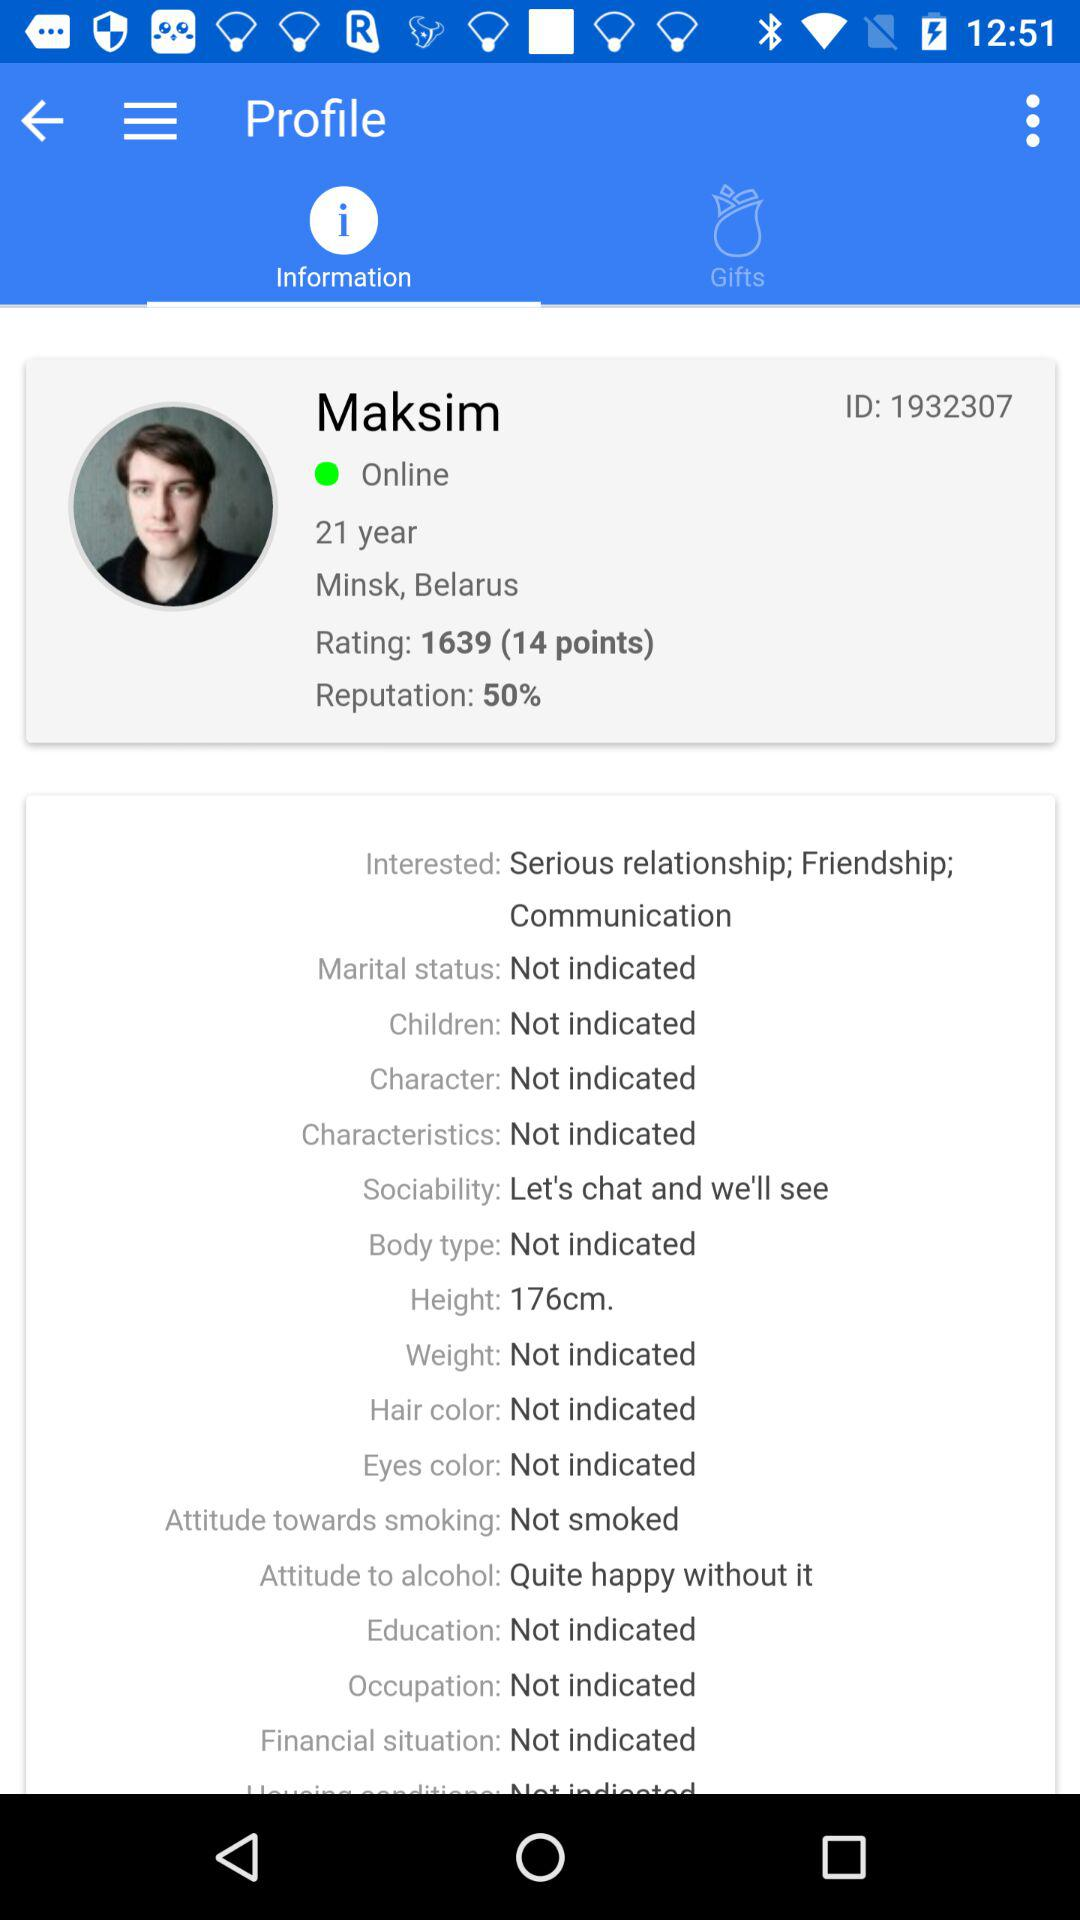How many more interested options does Maksim have than marital status options?
Answer the question using a single word or phrase. 2 